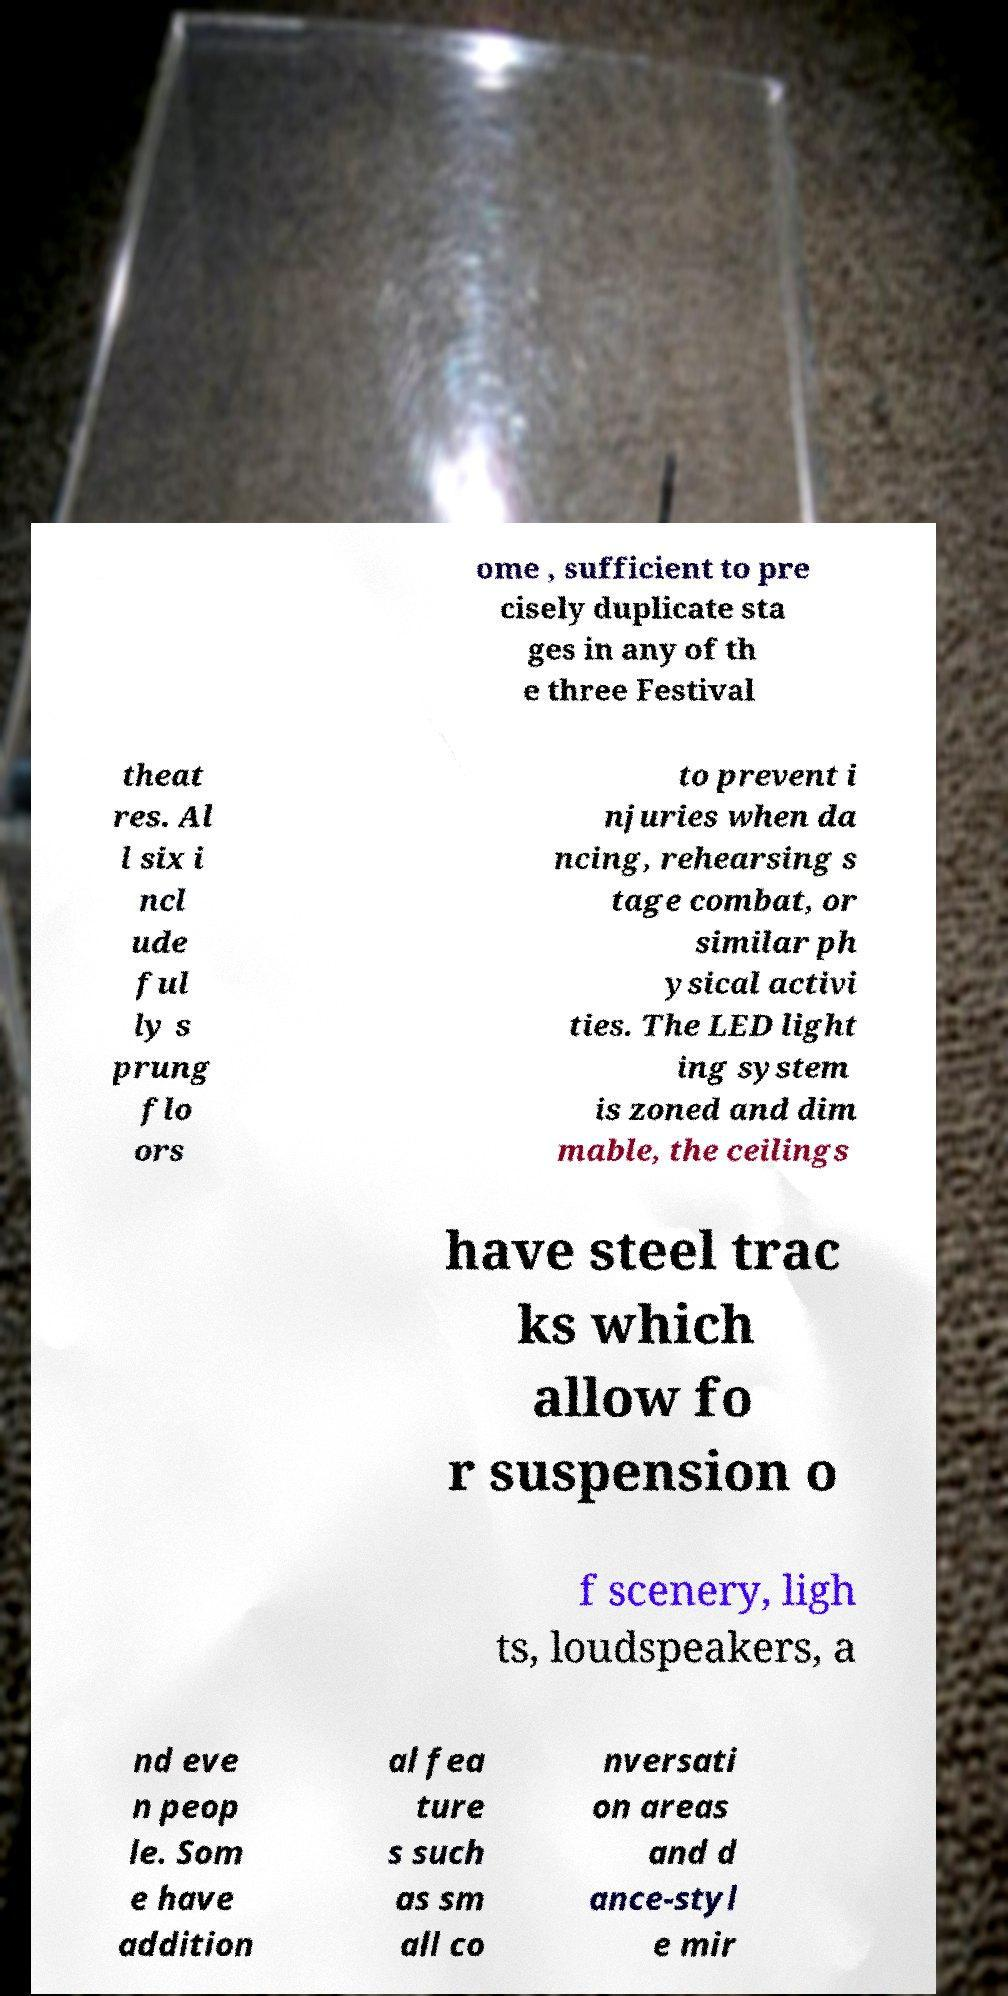Could you assist in decoding the text presented in this image and type it out clearly? ome , sufficient to pre cisely duplicate sta ges in any of th e three Festival theat res. Al l six i ncl ude ful ly s prung flo ors to prevent i njuries when da ncing, rehearsing s tage combat, or similar ph ysical activi ties. The LED light ing system is zoned and dim mable, the ceilings have steel trac ks which allow fo r suspension o f scenery, ligh ts, loudspeakers, a nd eve n peop le. Som e have addition al fea ture s such as sm all co nversati on areas and d ance-styl e mir 